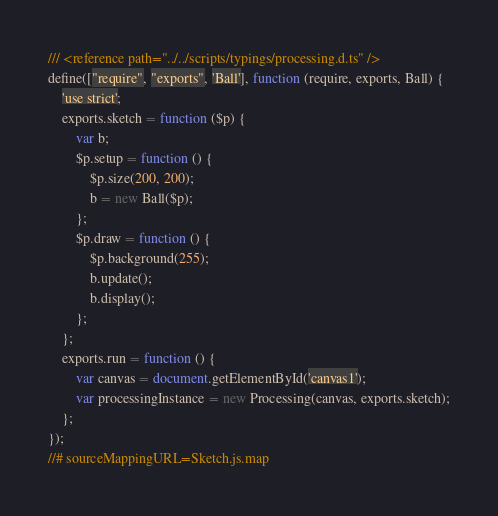Convert code to text. <code><loc_0><loc_0><loc_500><loc_500><_JavaScript_>/// <reference path="../../scripts/typings/processing.d.ts" />
define(["require", "exports", 'Ball'], function (require, exports, Ball) {
    'use strict';
    exports.sketch = function ($p) {
        var b;
        $p.setup = function () {
            $p.size(200, 200);
            b = new Ball($p);
        };
        $p.draw = function () {
            $p.background(255);
            b.update();
            b.display();
        };
    };
    exports.run = function () {
        var canvas = document.getElementById('canvas1');
        var processingInstance = new Processing(canvas, exports.sketch);
    };
});
//# sourceMappingURL=Sketch.js.map</code> 